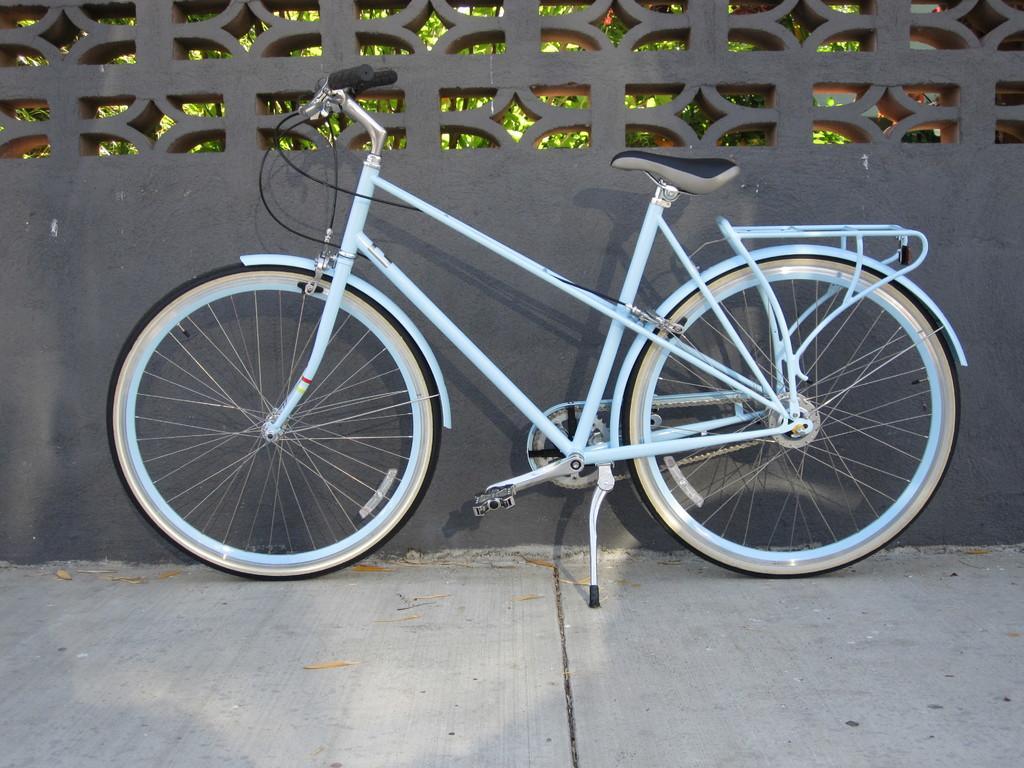How would you summarize this image in a sentence or two? In this image we can see there is a bicycle, behind the bicycle there's a wall and we can see behind the wall there are trees. 